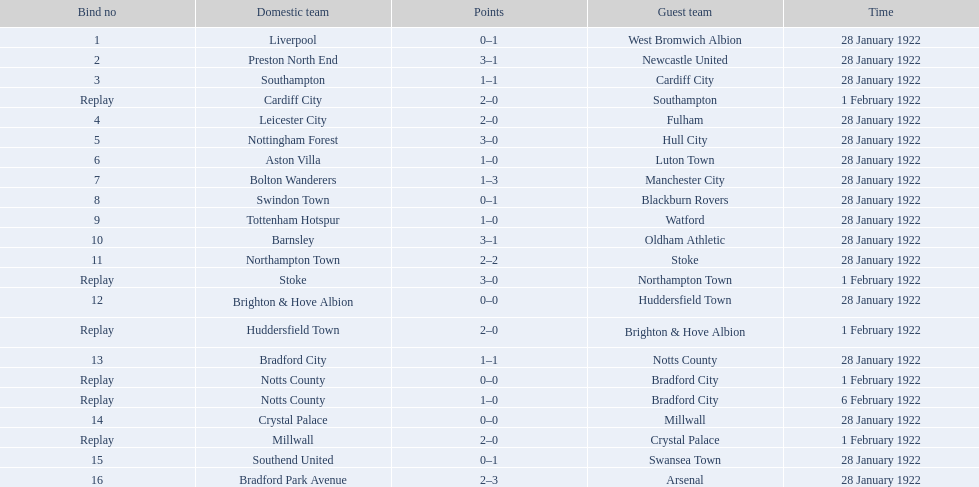Which team had a score of 0-1? Liverpool. Which team had a replay? Cardiff City. Which team had the same score as aston villa? Tottenham Hotspur. 